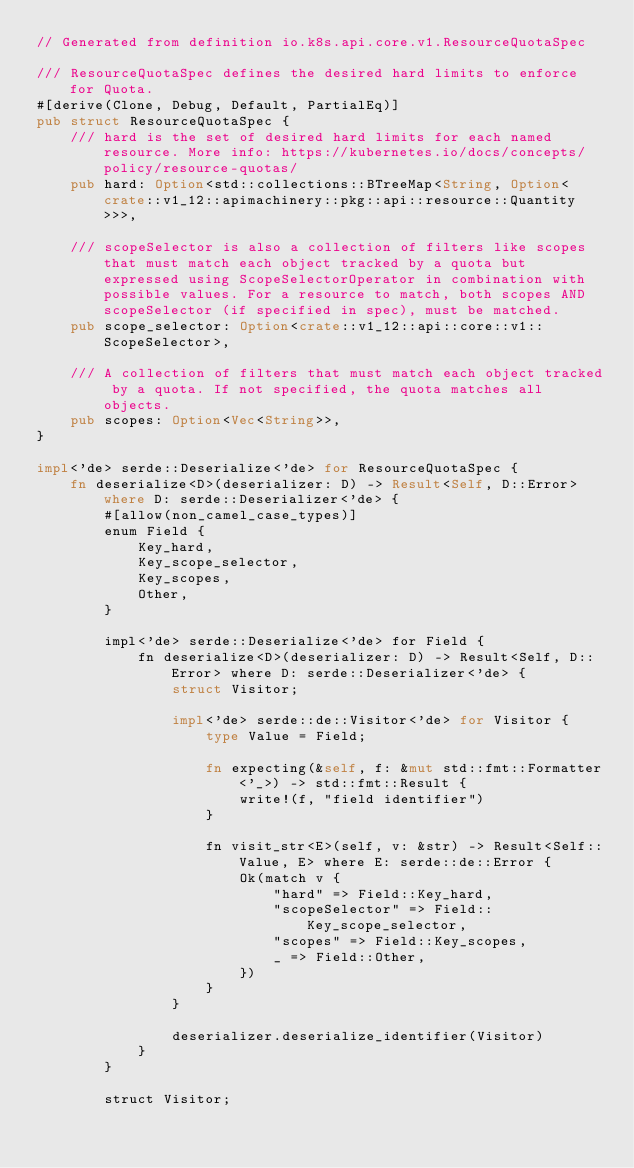<code> <loc_0><loc_0><loc_500><loc_500><_Rust_>// Generated from definition io.k8s.api.core.v1.ResourceQuotaSpec

/// ResourceQuotaSpec defines the desired hard limits to enforce for Quota.
#[derive(Clone, Debug, Default, PartialEq)]
pub struct ResourceQuotaSpec {
    /// hard is the set of desired hard limits for each named resource. More info: https://kubernetes.io/docs/concepts/policy/resource-quotas/
    pub hard: Option<std::collections::BTreeMap<String, Option<crate::v1_12::apimachinery::pkg::api::resource::Quantity>>>,

    /// scopeSelector is also a collection of filters like scopes that must match each object tracked by a quota but expressed using ScopeSelectorOperator in combination with possible values. For a resource to match, both scopes AND scopeSelector (if specified in spec), must be matched.
    pub scope_selector: Option<crate::v1_12::api::core::v1::ScopeSelector>,

    /// A collection of filters that must match each object tracked by a quota. If not specified, the quota matches all objects.
    pub scopes: Option<Vec<String>>,
}

impl<'de> serde::Deserialize<'de> for ResourceQuotaSpec {
    fn deserialize<D>(deserializer: D) -> Result<Self, D::Error> where D: serde::Deserializer<'de> {
        #[allow(non_camel_case_types)]
        enum Field {
            Key_hard,
            Key_scope_selector,
            Key_scopes,
            Other,
        }

        impl<'de> serde::Deserialize<'de> for Field {
            fn deserialize<D>(deserializer: D) -> Result<Self, D::Error> where D: serde::Deserializer<'de> {
                struct Visitor;

                impl<'de> serde::de::Visitor<'de> for Visitor {
                    type Value = Field;

                    fn expecting(&self, f: &mut std::fmt::Formatter<'_>) -> std::fmt::Result {
                        write!(f, "field identifier")
                    }

                    fn visit_str<E>(self, v: &str) -> Result<Self::Value, E> where E: serde::de::Error {
                        Ok(match v {
                            "hard" => Field::Key_hard,
                            "scopeSelector" => Field::Key_scope_selector,
                            "scopes" => Field::Key_scopes,
                            _ => Field::Other,
                        })
                    }
                }

                deserializer.deserialize_identifier(Visitor)
            }
        }

        struct Visitor;
</code> 